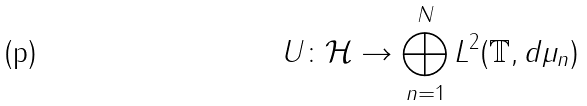<formula> <loc_0><loc_0><loc_500><loc_500>U \colon \mathcal { H } \rightarrow \bigoplus _ { n = 1 } ^ { N } L ^ { 2 } ( \mathbb { T } , d \mu _ { n } )</formula> 